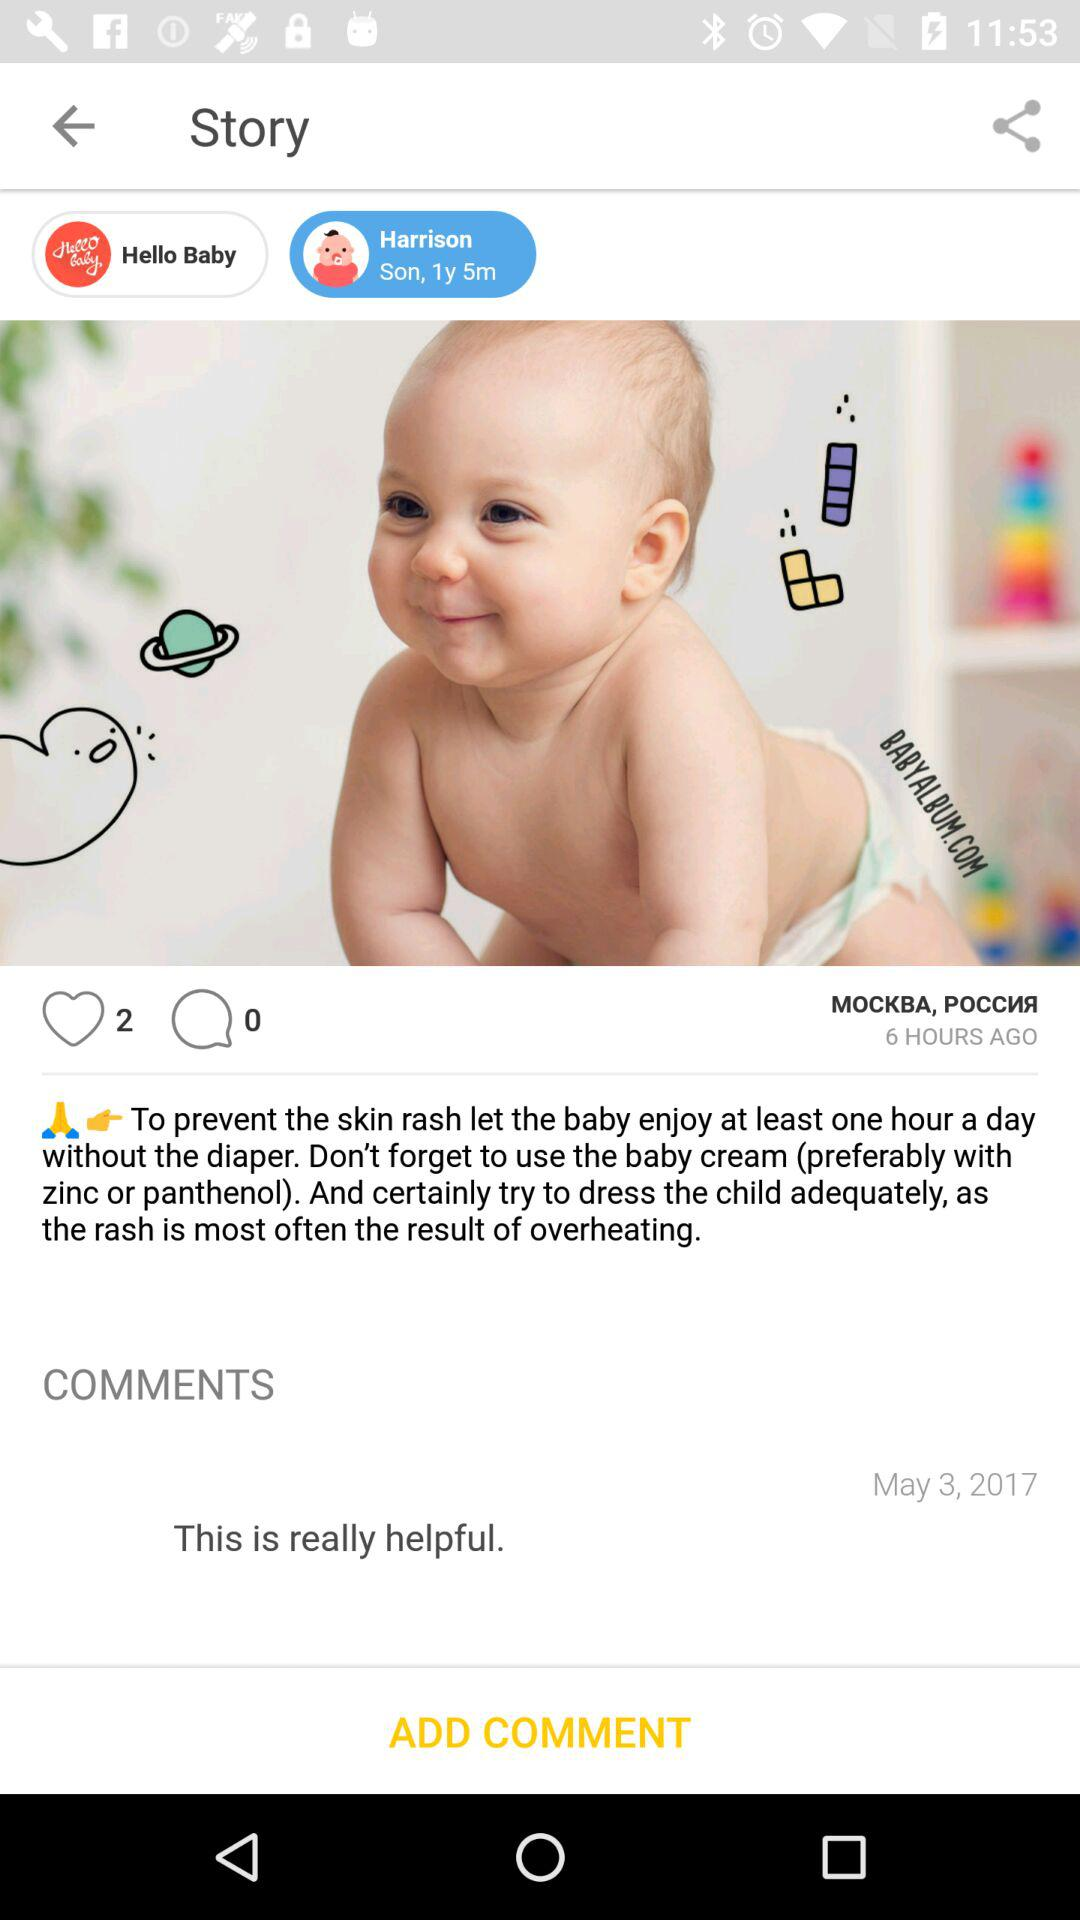How many comments are there? There are 0 comments. 